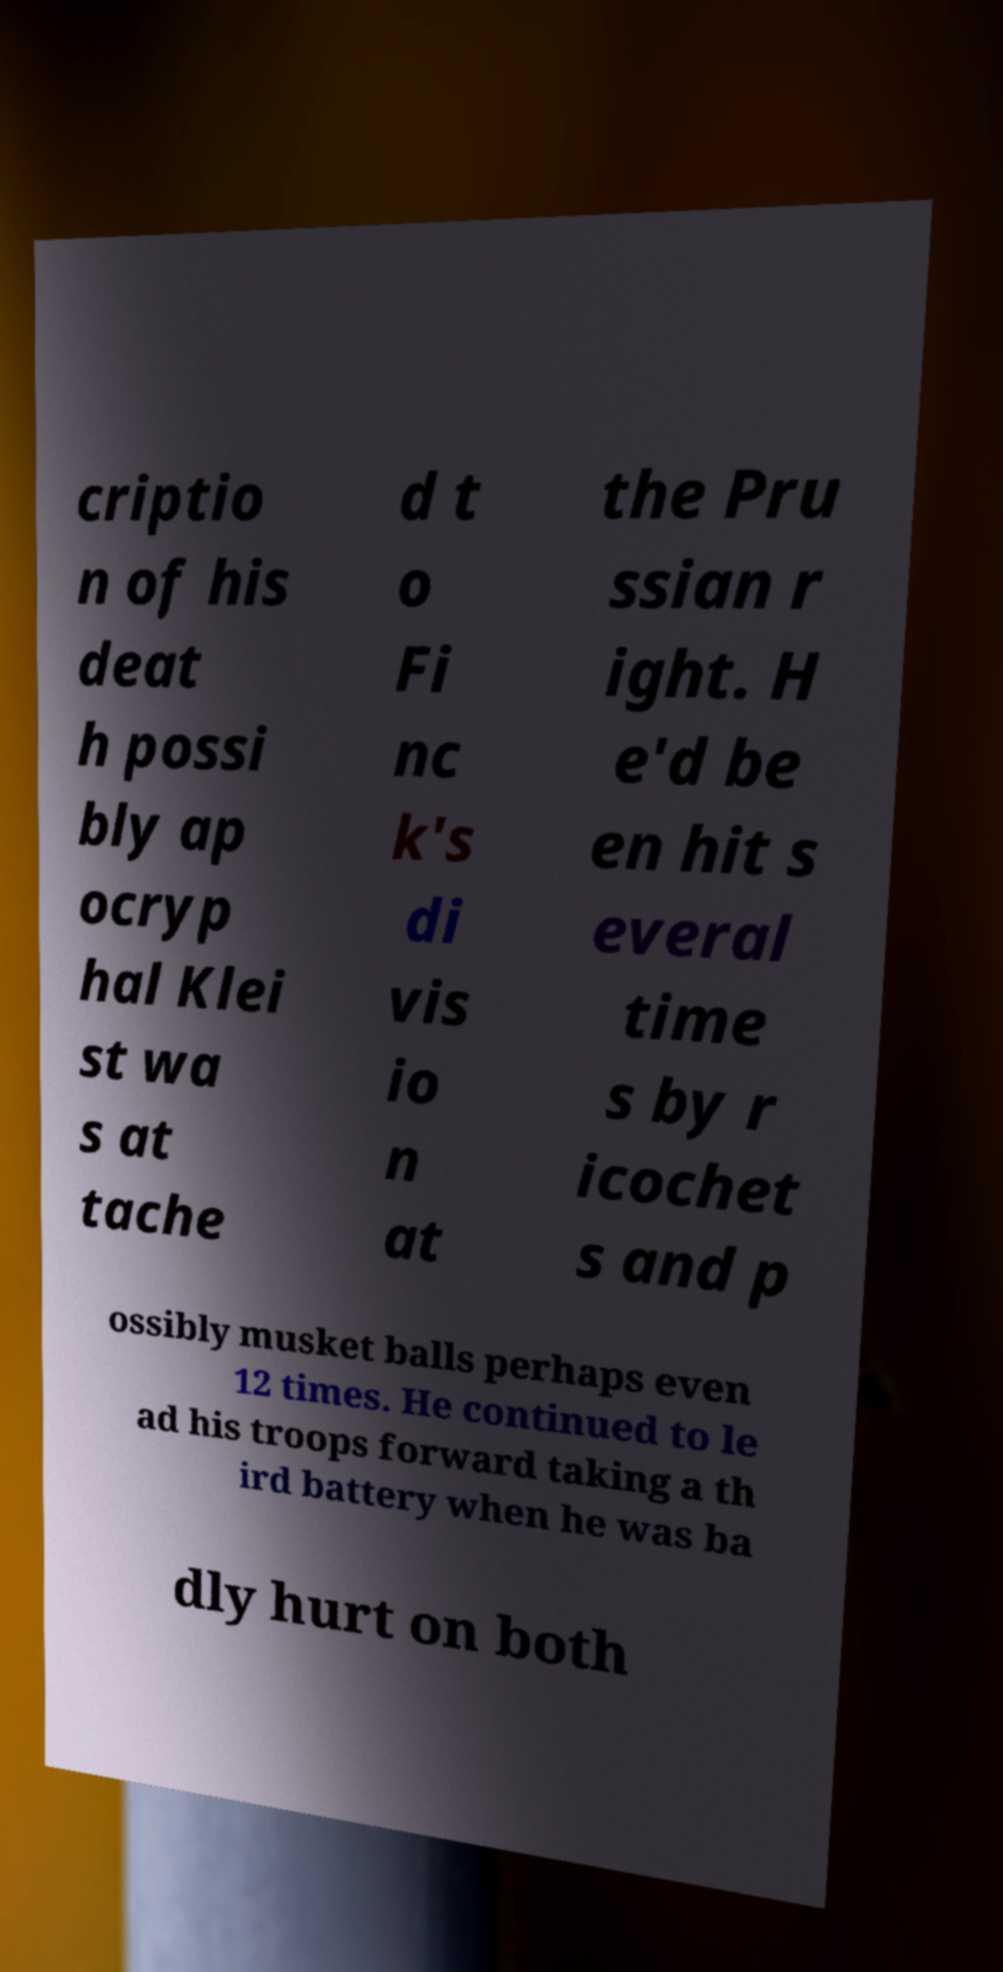Could you assist in decoding the text presented in this image and type it out clearly? criptio n of his deat h possi bly ap ocryp hal Klei st wa s at tache d t o Fi nc k's di vis io n at the Pru ssian r ight. H e'd be en hit s everal time s by r icochet s and p ossibly musket balls perhaps even 12 times. He continued to le ad his troops forward taking a th ird battery when he was ba dly hurt on both 